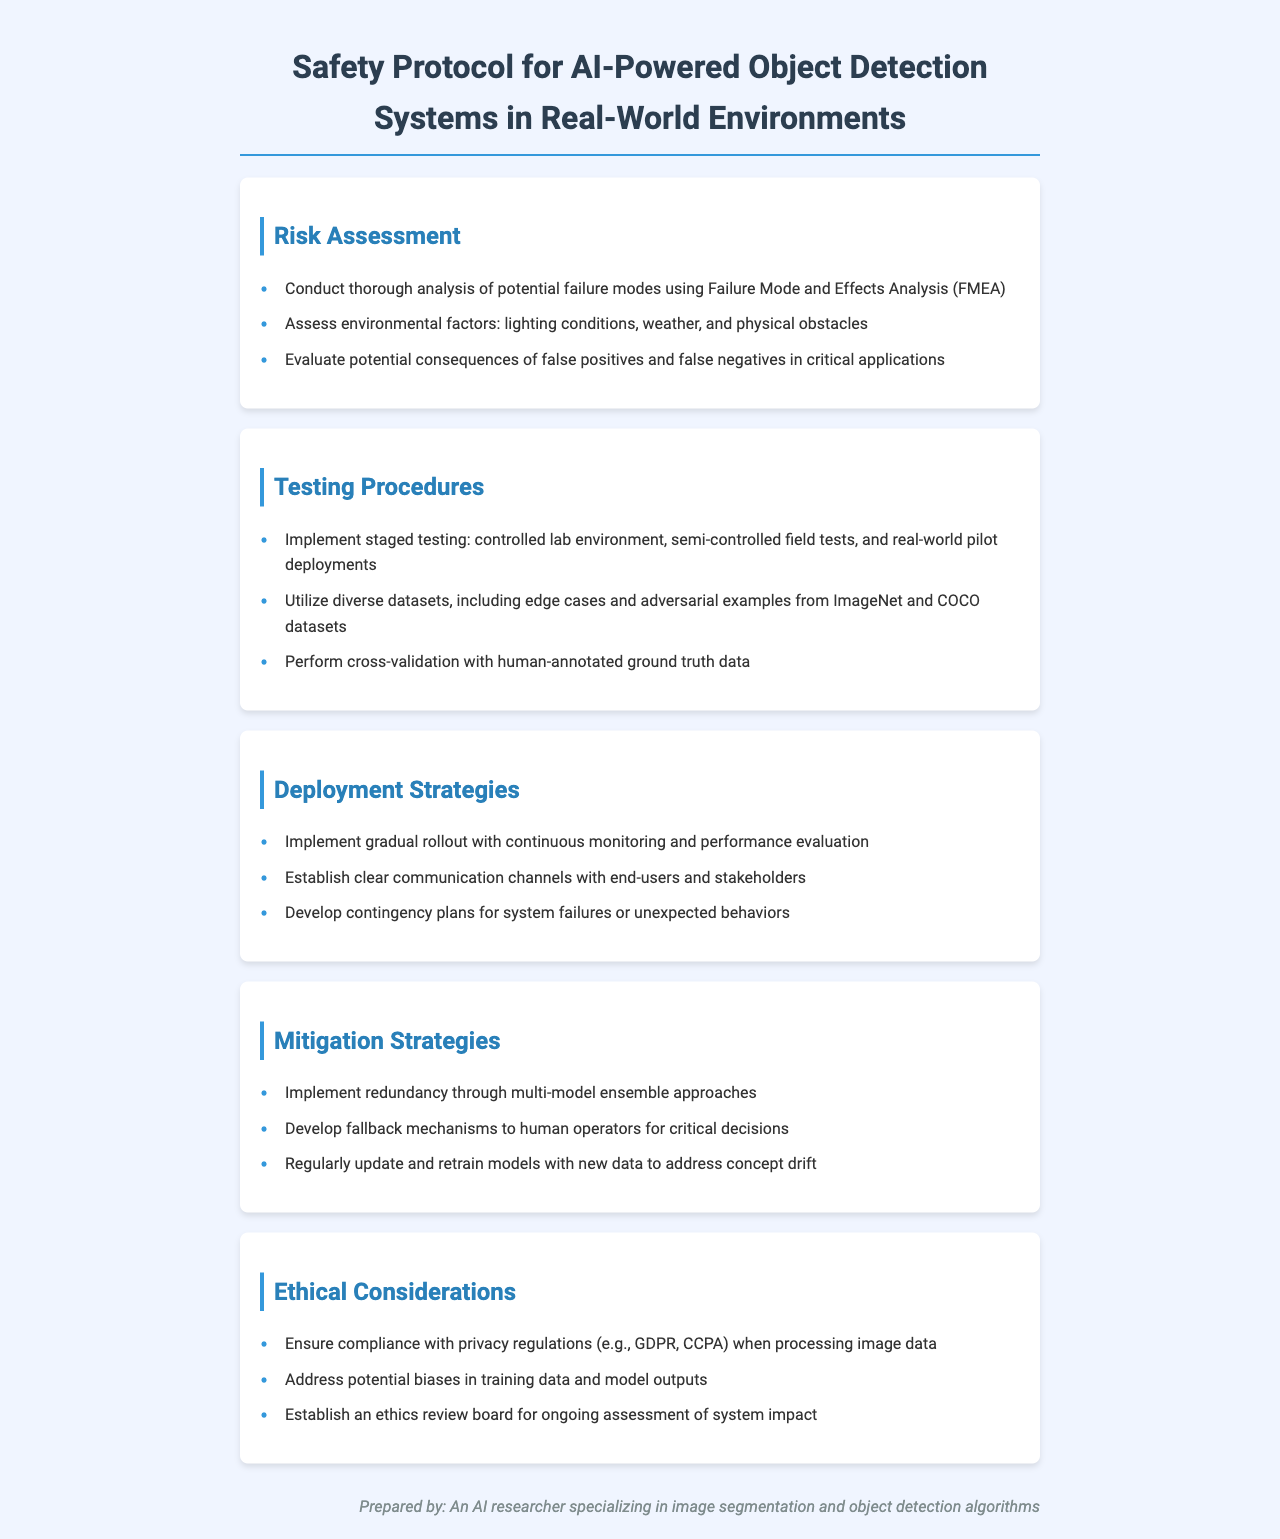What is the purpose of the document? The document outlines safety protocols for testing and deploying AI-powered object detection systems in real-world environments.
Answer: Safety Protocol for AI-Powered Object Detection Systems What analysis method is recommended for potential failure modes? The document suggests using Failure Mode and Effects Analysis (FMEA) for analyzing potential failure modes.
Answer: Failure Mode and Effects Analysis (FMEA) What testing stages are included in the testing procedures? The document details three stages of testing: controlled lab environment, semi-controlled field tests, and real-world pilot deployments.
Answer: Controlled lab environment, semi-controlled field tests, and real-world pilot deployments Which ethical regulation must be complied with regarding privacy? The document mentions compliance with GDPR and CCPA regarding privacy regulations when processing image data.
Answer: GDPR, CCPA What mechanism is suggested for critical decisions during system failures? The document advises developing fallback mechanisms to human operators for critical decisions in case of system failures.
Answer: Fallback mechanisms to human operators What is emphasized for deployment strategies? The document emphasizes a gradual rollout with continuous monitoring and performance evaluation during deployment.
Answer: Gradual rollout with continuous monitoring and performance evaluation What type of testing data is recommended to utilize? The document recommends utilizing diverse datasets, including edge cases and adversarial examples from ImageNet and COCO datasets.
Answer: Diverse datasets, including edge cases and adversarial examples from ImageNet and COCO What is one of the suggested mitigation strategies for model updates? The document states that regularly updating and retraining models with new data is a mitigation strategy to address concept drift.
Answer: Regularly update and retrain models with new data What kind of board is recommended for ongoing assessments? The document suggests establishing an ethics review board for ongoing assessment of system impact.
Answer: Ethics review board 